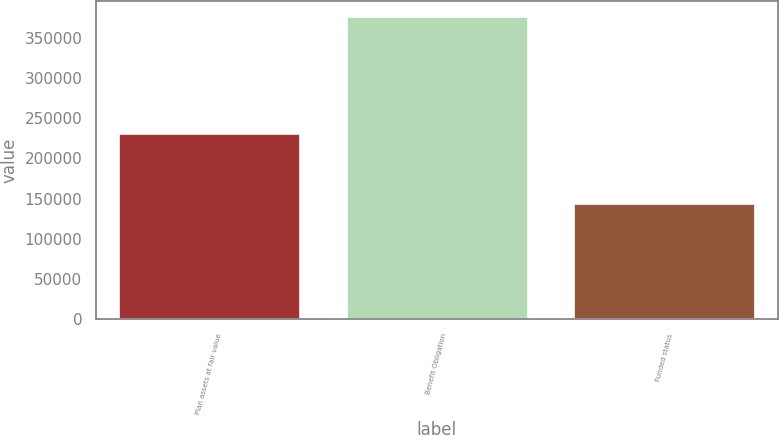Convert chart. <chart><loc_0><loc_0><loc_500><loc_500><bar_chart><fcel>Plan assets at fair value<fcel>Benefit Obligation<fcel>Funded status<nl><fcel>232175<fcel>376649<fcel>144474<nl></chart> 